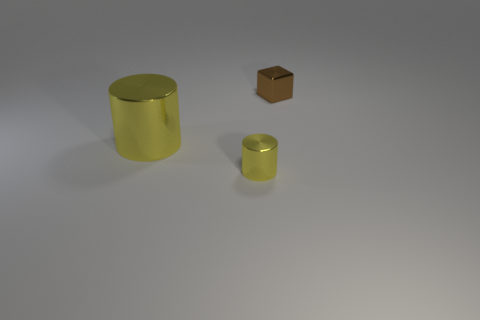Can you describe the shapes and sizes of the objects in the image? Certainly! The image depicts three objects. Starting from the left, there is a large yellow cylinder that appears to be quite tall compared to its diameter. To the right, there is a much smaller object which is a golden-colored cylindrical container; it's a miniature version compared to the larger one. Finally, there's a small brown cube that is distinct not only in its color but also in geometry, contrasting sharply with the rounded shapes of the other two objects. 